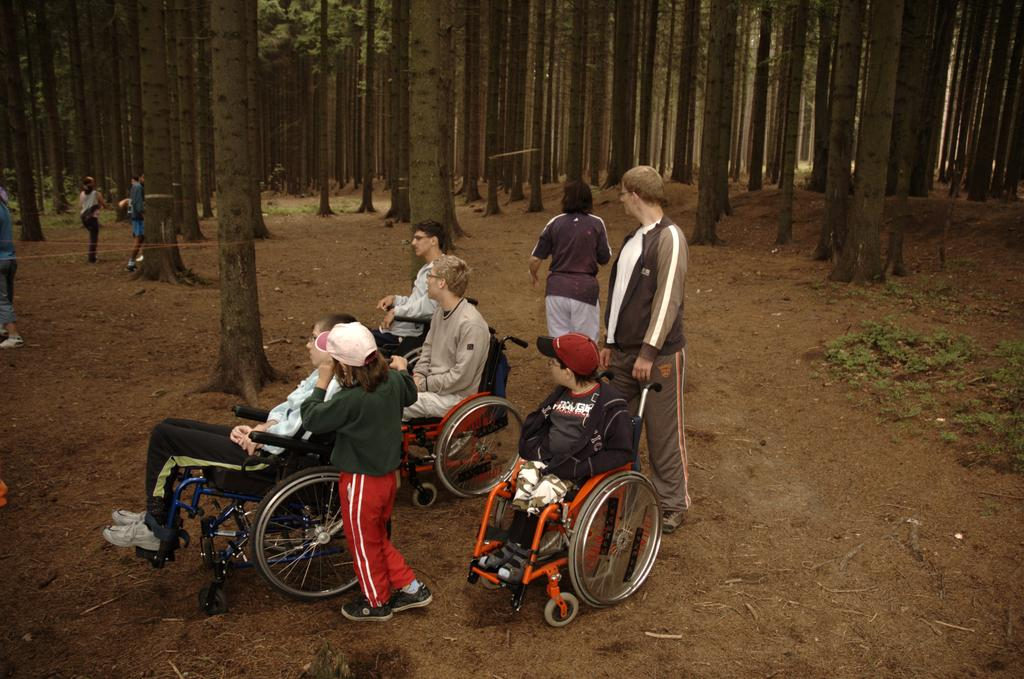What are the people in the image doing? The persons standing on the ground and sitting in wheelchairs are present in the image. What can be seen in the background of the image? There are trees and grass in the background of the image. What type of copper material is visible on the cushion in the image? There is no copper or cushion present in the image. How many ducks are swimming in the grass in the image? There are no ducks present in the image; it features persons standing and sitting in a grassy area with trees in the background. 